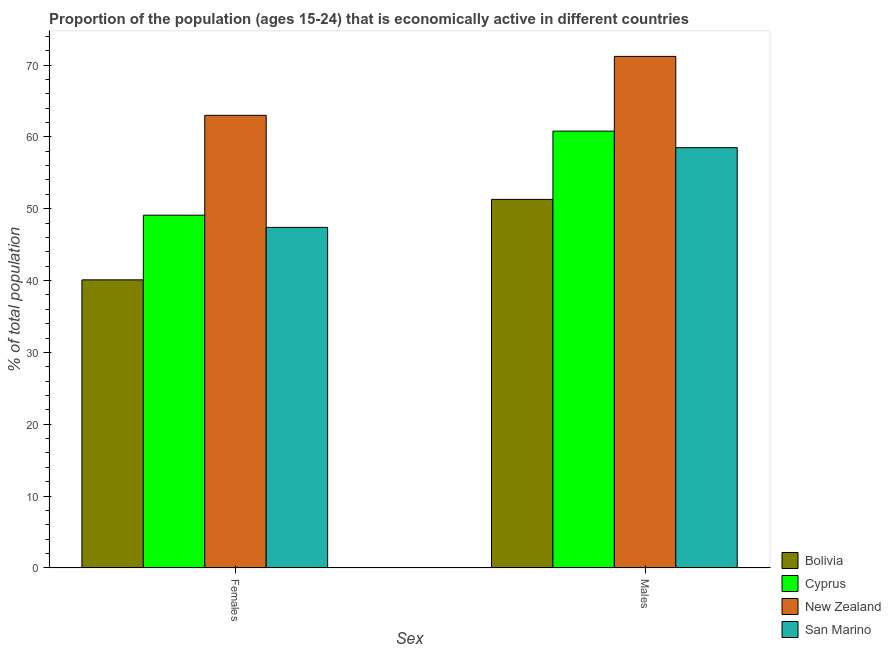How many bars are there on the 1st tick from the right?
Ensure brevity in your answer.  4. What is the label of the 2nd group of bars from the left?
Provide a short and direct response. Males. What is the percentage of economically active female population in Bolivia?
Ensure brevity in your answer.  40.1. Across all countries, what is the maximum percentage of economically active male population?
Keep it short and to the point. 71.2. Across all countries, what is the minimum percentage of economically active male population?
Keep it short and to the point. 51.3. In which country was the percentage of economically active female population maximum?
Offer a terse response. New Zealand. In which country was the percentage of economically active female population minimum?
Your answer should be very brief. Bolivia. What is the total percentage of economically active male population in the graph?
Keep it short and to the point. 241.8. What is the difference between the percentage of economically active male population in San Marino and that in Cyprus?
Give a very brief answer. -2.3. What is the difference between the percentage of economically active female population in Bolivia and the percentage of economically active male population in Cyprus?
Offer a terse response. -20.7. What is the average percentage of economically active female population per country?
Offer a very short reply. 49.9. What is the difference between the percentage of economically active male population and percentage of economically active female population in Cyprus?
Ensure brevity in your answer.  11.7. In how many countries, is the percentage of economically active female population greater than 72 %?
Offer a terse response. 0. What is the ratio of the percentage of economically active female population in San Marino to that in Bolivia?
Keep it short and to the point. 1.18. Is the percentage of economically active male population in San Marino less than that in Cyprus?
Offer a very short reply. Yes. What does the 3rd bar from the left in Males represents?
Offer a terse response. New Zealand. What does the 3rd bar from the right in Females represents?
Offer a terse response. Cyprus. Are all the bars in the graph horizontal?
Keep it short and to the point. No. Does the graph contain grids?
Your answer should be compact. No. Where does the legend appear in the graph?
Provide a short and direct response. Bottom right. How many legend labels are there?
Make the answer very short. 4. What is the title of the graph?
Keep it short and to the point. Proportion of the population (ages 15-24) that is economically active in different countries. What is the label or title of the X-axis?
Keep it short and to the point. Sex. What is the label or title of the Y-axis?
Your response must be concise. % of total population. What is the % of total population in Bolivia in Females?
Provide a short and direct response. 40.1. What is the % of total population of Cyprus in Females?
Your answer should be very brief. 49.1. What is the % of total population of New Zealand in Females?
Ensure brevity in your answer.  63. What is the % of total population in San Marino in Females?
Keep it short and to the point. 47.4. What is the % of total population of Bolivia in Males?
Provide a short and direct response. 51.3. What is the % of total population of Cyprus in Males?
Give a very brief answer. 60.8. What is the % of total population of New Zealand in Males?
Ensure brevity in your answer.  71.2. What is the % of total population of San Marino in Males?
Offer a terse response. 58.5. Across all Sex, what is the maximum % of total population of Bolivia?
Ensure brevity in your answer.  51.3. Across all Sex, what is the maximum % of total population of Cyprus?
Ensure brevity in your answer.  60.8. Across all Sex, what is the maximum % of total population in New Zealand?
Offer a very short reply. 71.2. Across all Sex, what is the maximum % of total population of San Marino?
Your answer should be very brief. 58.5. Across all Sex, what is the minimum % of total population of Bolivia?
Your response must be concise. 40.1. Across all Sex, what is the minimum % of total population in Cyprus?
Offer a very short reply. 49.1. Across all Sex, what is the minimum % of total population in San Marino?
Your answer should be compact. 47.4. What is the total % of total population in Bolivia in the graph?
Offer a terse response. 91.4. What is the total % of total population in Cyprus in the graph?
Your response must be concise. 109.9. What is the total % of total population in New Zealand in the graph?
Make the answer very short. 134.2. What is the total % of total population in San Marino in the graph?
Ensure brevity in your answer.  105.9. What is the difference between the % of total population of Bolivia in Females and that in Males?
Ensure brevity in your answer.  -11.2. What is the difference between the % of total population of New Zealand in Females and that in Males?
Ensure brevity in your answer.  -8.2. What is the difference between the % of total population in Bolivia in Females and the % of total population in Cyprus in Males?
Make the answer very short. -20.7. What is the difference between the % of total population of Bolivia in Females and the % of total population of New Zealand in Males?
Keep it short and to the point. -31.1. What is the difference between the % of total population of Bolivia in Females and the % of total population of San Marino in Males?
Keep it short and to the point. -18.4. What is the difference between the % of total population in Cyprus in Females and the % of total population in New Zealand in Males?
Ensure brevity in your answer.  -22.1. What is the average % of total population of Bolivia per Sex?
Offer a very short reply. 45.7. What is the average % of total population of Cyprus per Sex?
Your answer should be very brief. 54.95. What is the average % of total population of New Zealand per Sex?
Give a very brief answer. 67.1. What is the average % of total population of San Marino per Sex?
Give a very brief answer. 52.95. What is the difference between the % of total population of Bolivia and % of total population of Cyprus in Females?
Your response must be concise. -9. What is the difference between the % of total population in Bolivia and % of total population in New Zealand in Females?
Provide a short and direct response. -22.9. What is the difference between the % of total population of Bolivia and % of total population of San Marino in Females?
Your response must be concise. -7.3. What is the difference between the % of total population of Cyprus and % of total population of San Marino in Females?
Your answer should be very brief. 1.7. What is the difference between the % of total population in New Zealand and % of total population in San Marino in Females?
Provide a short and direct response. 15.6. What is the difference between the % of total population in Bolivia and % of total population in New Zealand in Males?
Keep it short and to the point. -19.9. What is the ratio of the % of total population in Bolivia in Females to that in Males?
Ensure brevity in your answer.  0.78. What is the ratio of the % of total population of Cyprus in Females to that in Males?
Your answer should be compact. 0.81. What is the ratio of the % of total population of New Zealand in Females to that in Males?
Offer a terse response. 0.88. What is the ratio of the % of total population in San Marino in Females to that in Males?
Your response must be concise. 0.81. What is the difference between the highest and the second highest % of total population in Bolivia?
Your answer should be compact. 11.2. What is the difference between the highest and the second highest % of total population of Cyprus?
Provide a succinct answer. 11.7. What is the difference between the highest and the second highest % of total population in San Marino?
Give a very brief answer. 11.1. What is the difference between the highest and the lowest % of total population in Bolivia?
Your response must be concise. 11.2. 